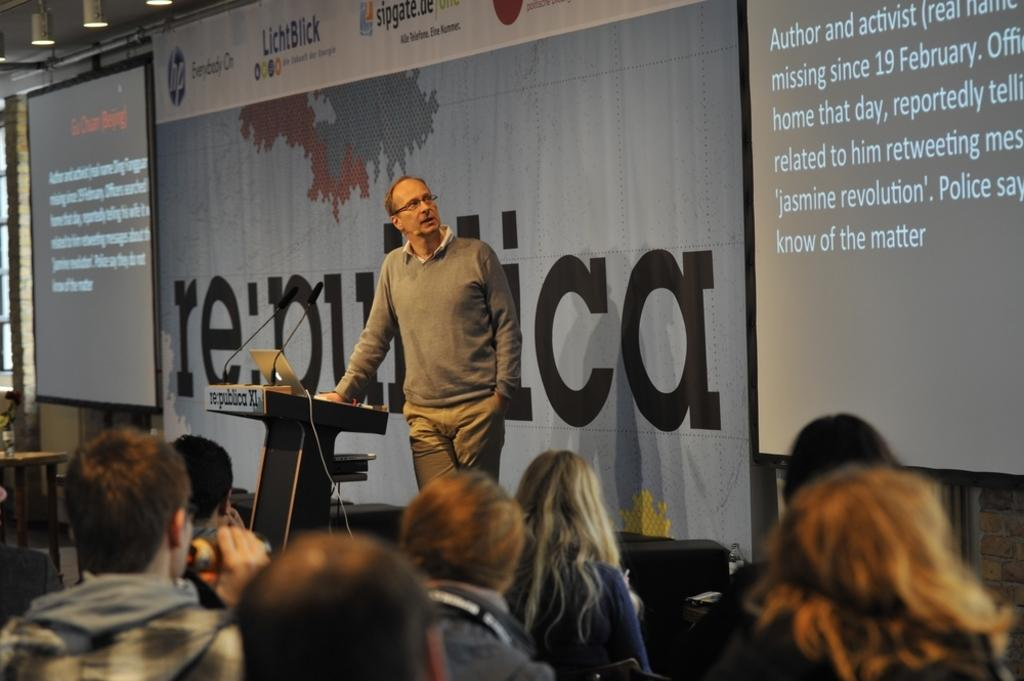What objects are present in the image that are used for displaying information? There are screens in the image. What objects in the image provide illumination? There are lights in the image. What piece of furniture is present in the image? There is a table in the image. What objects in the image are used for amplifying sound? There are microphones (mics) in the image. What electronic device is present in the image? There is a laptop in the image. How many people are present in the image? There is a group of people in the image. What type of building can be seen in the background of the image? There is no building present in the image. Can you tell me how many moms are in the image? The term "mom" is not mentioned in the provided facts, and there is no indication of any mothers in the image. Is the image? There is no camp present in the image. 